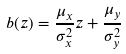Convert formula to latex. <formula><loc_0><loc_0><loc_500><loc_500>b ( z ) = \frac { \mu _ { x } } { \sigma _ { x } ^ { 2 } } z + \frac { \mu _ { y } } { \sigma _ { y } ^ { 2 } }</formula> 